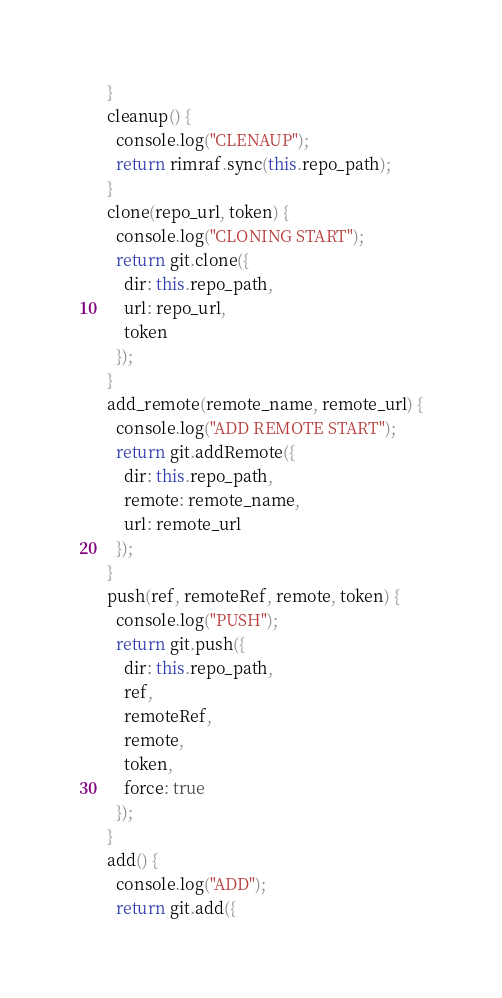Convert code to text. <code><loc_0><loc_0><loc_500><loc_500><_JavaScript_>  }
  cleanup() {
    console.log("CLENAUP");
    return rimraf.sync(this.repo_path);
  }
  clone(repo_url, token) {
    console.log("CLONING START");
    return git.clone({
      dir: this.repo_path,
      url: repo_url,
      token
    });
  }
  add_remote(remote_name, remote_url) {
    console.log("ADD REMOTE START");
    return git.addRemote({
      dir: this.repo_path,
      remote: remote_name,
      url: remote_url
    });
  }
  push(ref, remoteRef, remote, token) {
    console.log("PUSH");
    return git.push({
      dir: this.repo_path,
      ref,
      remoteRef,
      remote,
      token,
      force: true
    });
  }
  add() {
    console.log("ADD");
    return git.add({</code> 